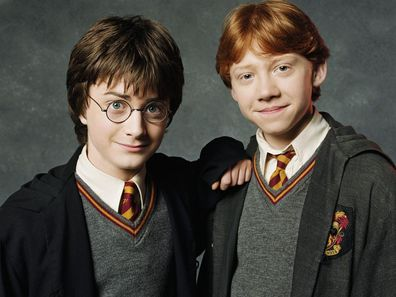Describe the following image. This image features actors Daniel Radcliffe and Rupert Grint, who are widely recognized for their roles as Harry Potter and Ron Weasley in the beloved Harry Potter film series. The actors are standing side by side against a dark gray background. Daniel Radcliffe, positioned on the left, portrays Harry Potter and is seen wearing iconic round glasses with a bemused expression on his face. He is dressed in a Hogwarts uniform, consisting of a black robe adorned with the Gryffindor house crest on the left breast, a white collared shirt, and a striped tie in red and gold colors reflecting his house. Rupert Grint, on the right, embodies Ron Weasley and has a slight smile on his face, also dressed in the Gryffindor school uniform. The actors' attire and expressions evoke the magical and adventurous spirit of the Harry Potter series. 